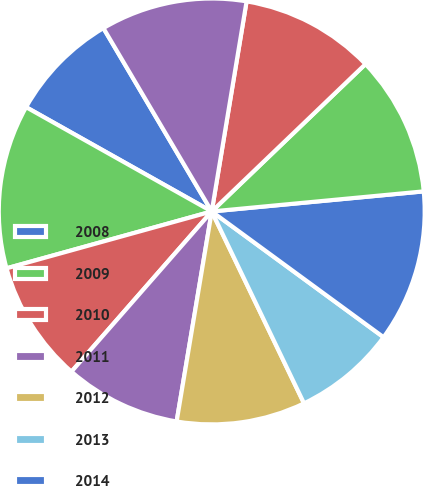<chart> <loc_0><loc_0><loc_500><loc_500><pie_chart><fcel>2008<fcel>2009<fcel>2010<fcel>2011<fcel>2012<fcel>2013<fcel>2014<fcel>2016<fcel>2017<fcel>2018<nl><fcel>8.36%<fcel>12.45%<fcel>9.25%<fcel>8.81%<fcel>9.77%<fcel>7.81%<fcel>11.56%<fcel>10.66%<fcel>10.22%<fcel>11.11%<nl></chart> 